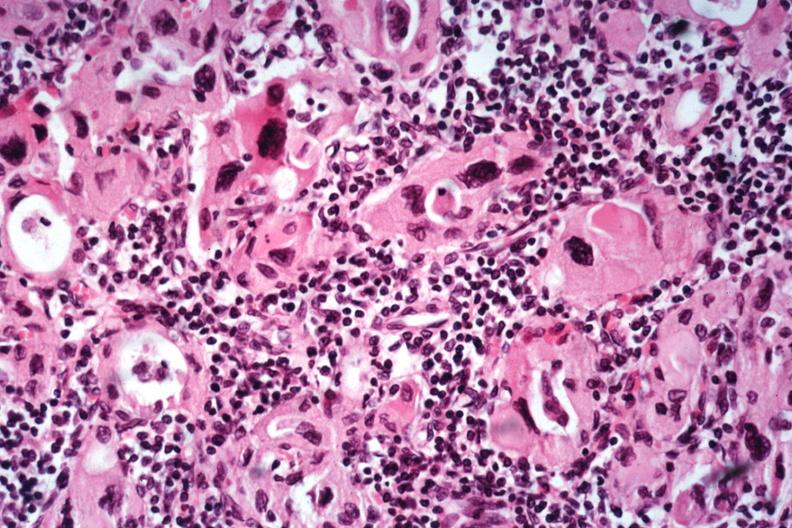where is this part in the figure?
Answer the question using a single word or phrase. Endocrine system 